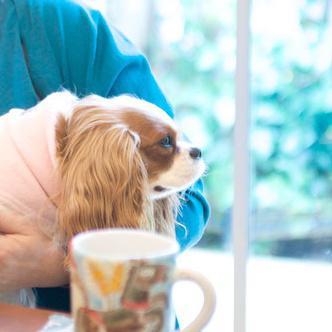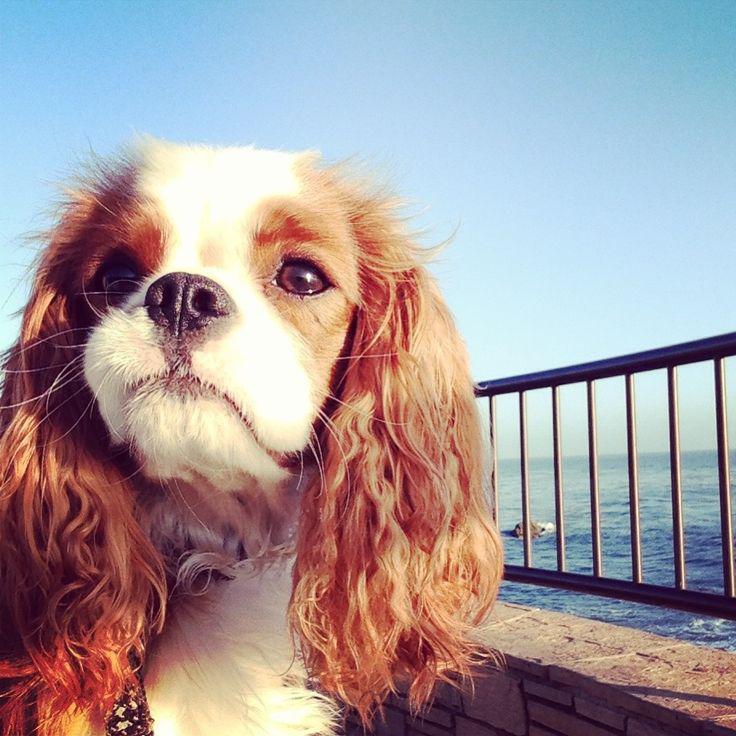The first image is the image on the left, the second image is the image on the right. Assess this claim about the two images: "Part of a human is visible in at least one of the images.". Correct or not? Answer yes or no. Yes. The first image is the image on the left, the second image is the image on the right. Assess this claim about the two images: "At least one image shows a spaniel on a solid blue background, and at least one image shows a spaniel gazing upward and to the left.". Correct or not? Answer yes or no. No. 